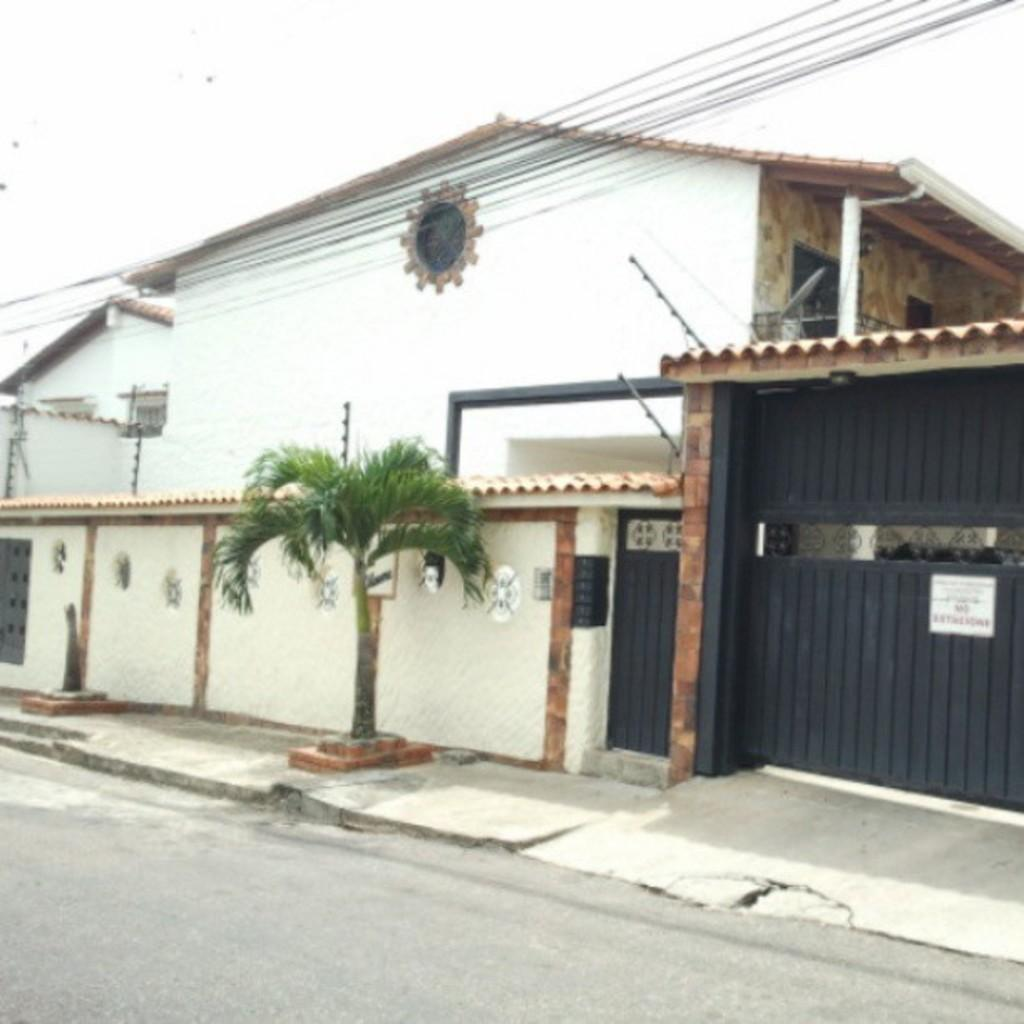What type of structures can be seen in the image? There are houses in the image. What other objects are present near the houses? There are gates and posters visible in the image. What type of vegetation is present in the image? There is a tree in the image. What is visible at the top of the image? The sky is visible at the top of the image. What can be seen at the bottom of the image? There is a road visible at the bottom of the image. What type of food is being offered by the beggar in the image? There is no beggar present in the image, so it is not possible to answer that question. 